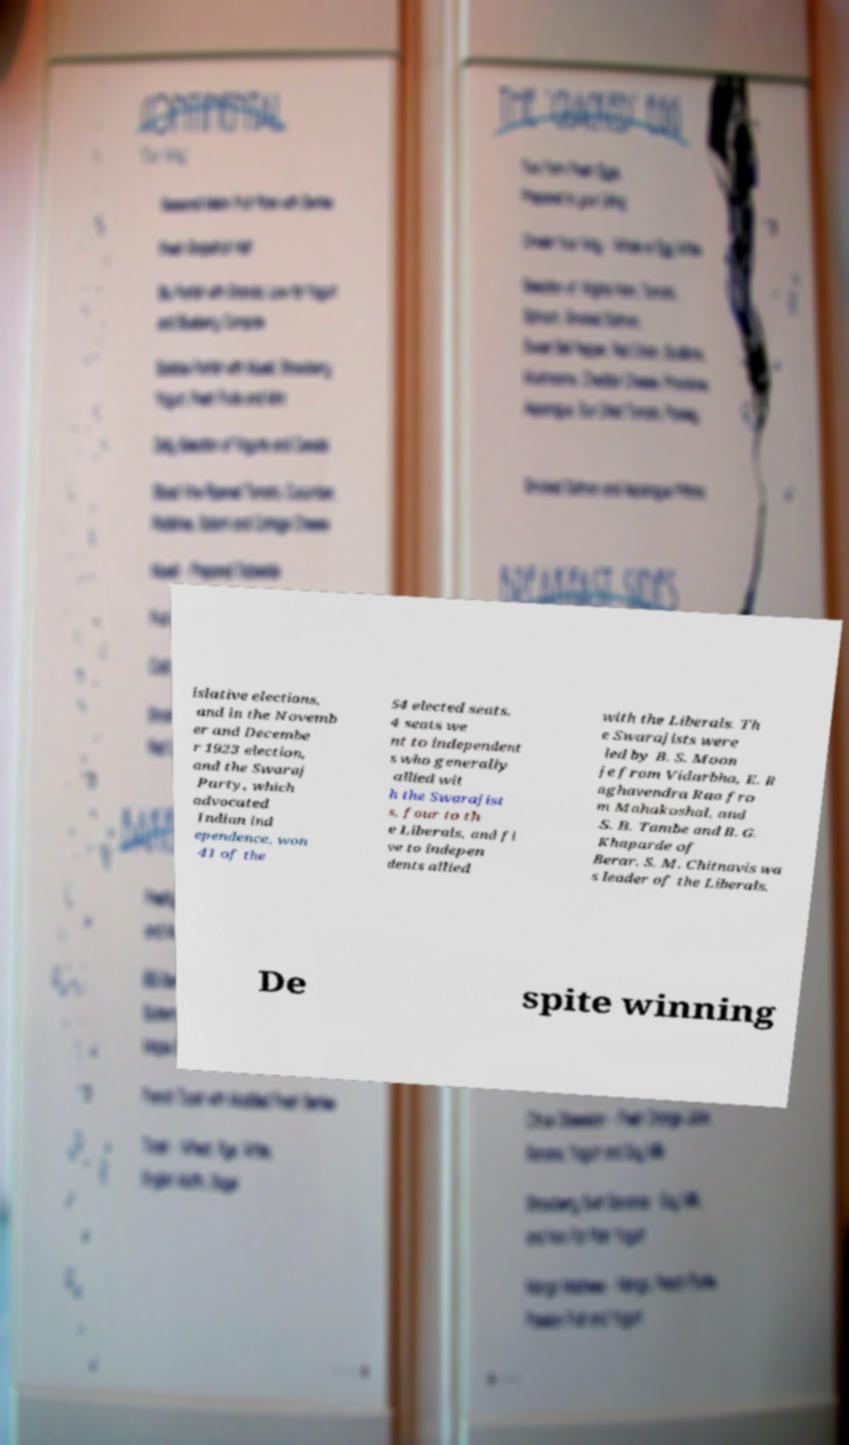For documentation purposes, I need the text within this image transcribed. Could you provide that? islative elections, and in the Novemb er and Decembe r 1923 election, and the Swaraj Party, which advocated Indian ind ependence, won 41 of the 54 elected seats. 4 seats we nt to independent s who generally allied wit h the Swarajist s, four to th e Liberals, and fi ve to indepen dents allied with the Liberals. Th e Swarajists were led by B. S. Moon je from Vidarbha, E. R aghavendra Rao fro m Mahakoshal, and S. B. Tambe and B. G. Khaparde of Berar. S. M. Chitnavis wa s leader of the Liberals. De spite winning 